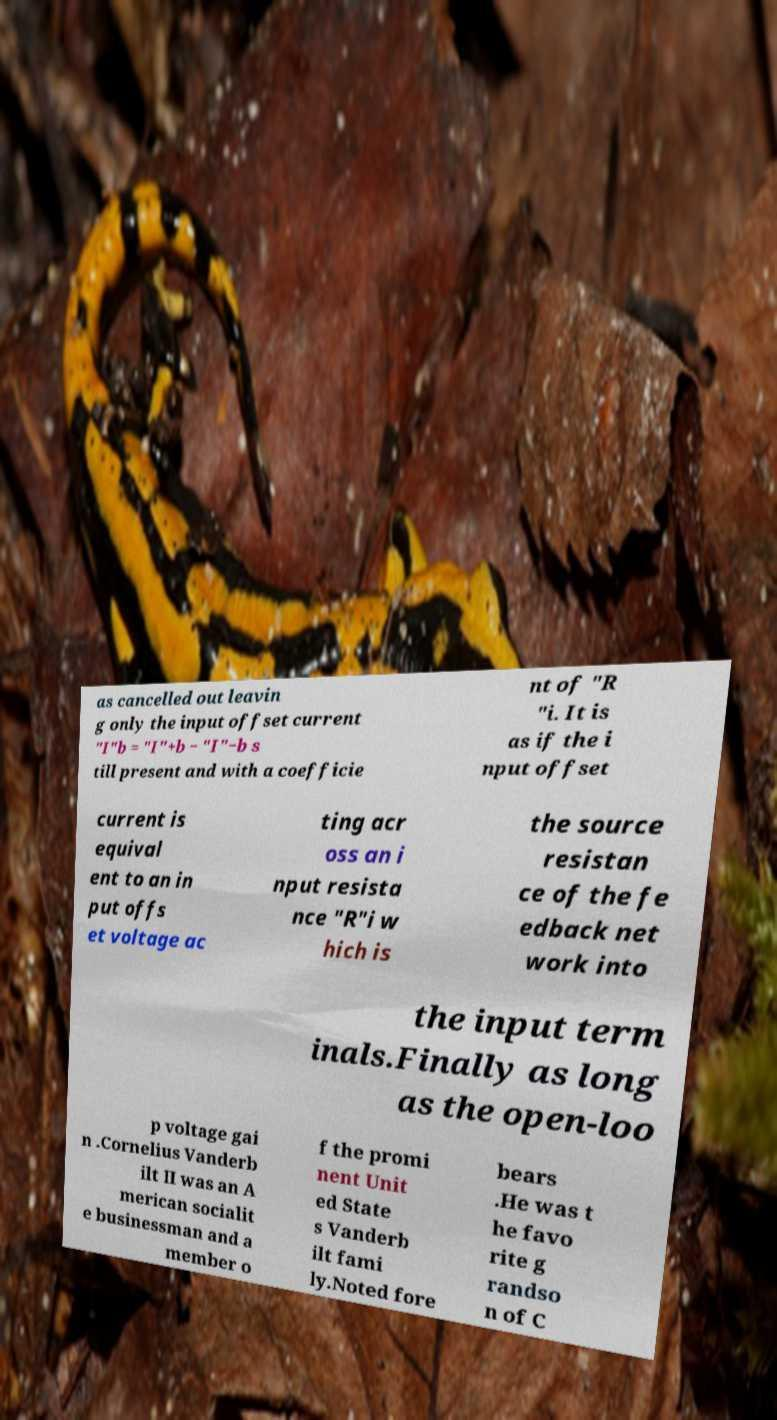Please identify and transcribe the text found in this image. as cancelled out leavin g only the input offset current "I"b = "I"+b − "I"−b s till present and with a coefficie nt of "R "i. It is as if the i nput offset current is equival ent to an in put offs et voltage ac ting acr oss an i nput resista nce "R"i w hich is the source resistan ce of the fe edback net work into the input term inals.Finally as long as the open-loo p voltage gai n .Cornelius Vanderb ilt II was an A merican socialit e businessman and a member o f the promi nent Unit ed State s Vanderb ilt fami ly.Noted fore bears .He was t he favo rite g randso n of C 